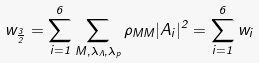<formula> <loc_0><loc_0><loc_500><loc_500>w _ { \frac { 3 } { 2 } } = \sum _ { i = 1 } ^ { 6 } \sum _ { M , \lambda _ { \Lambda } , \lambda _ { p } } \rho _ { M M } | A _ { i } | ^ { 2 } = \sum _ { i = 1 } ^ { 6 } w _ { i }</formula> 